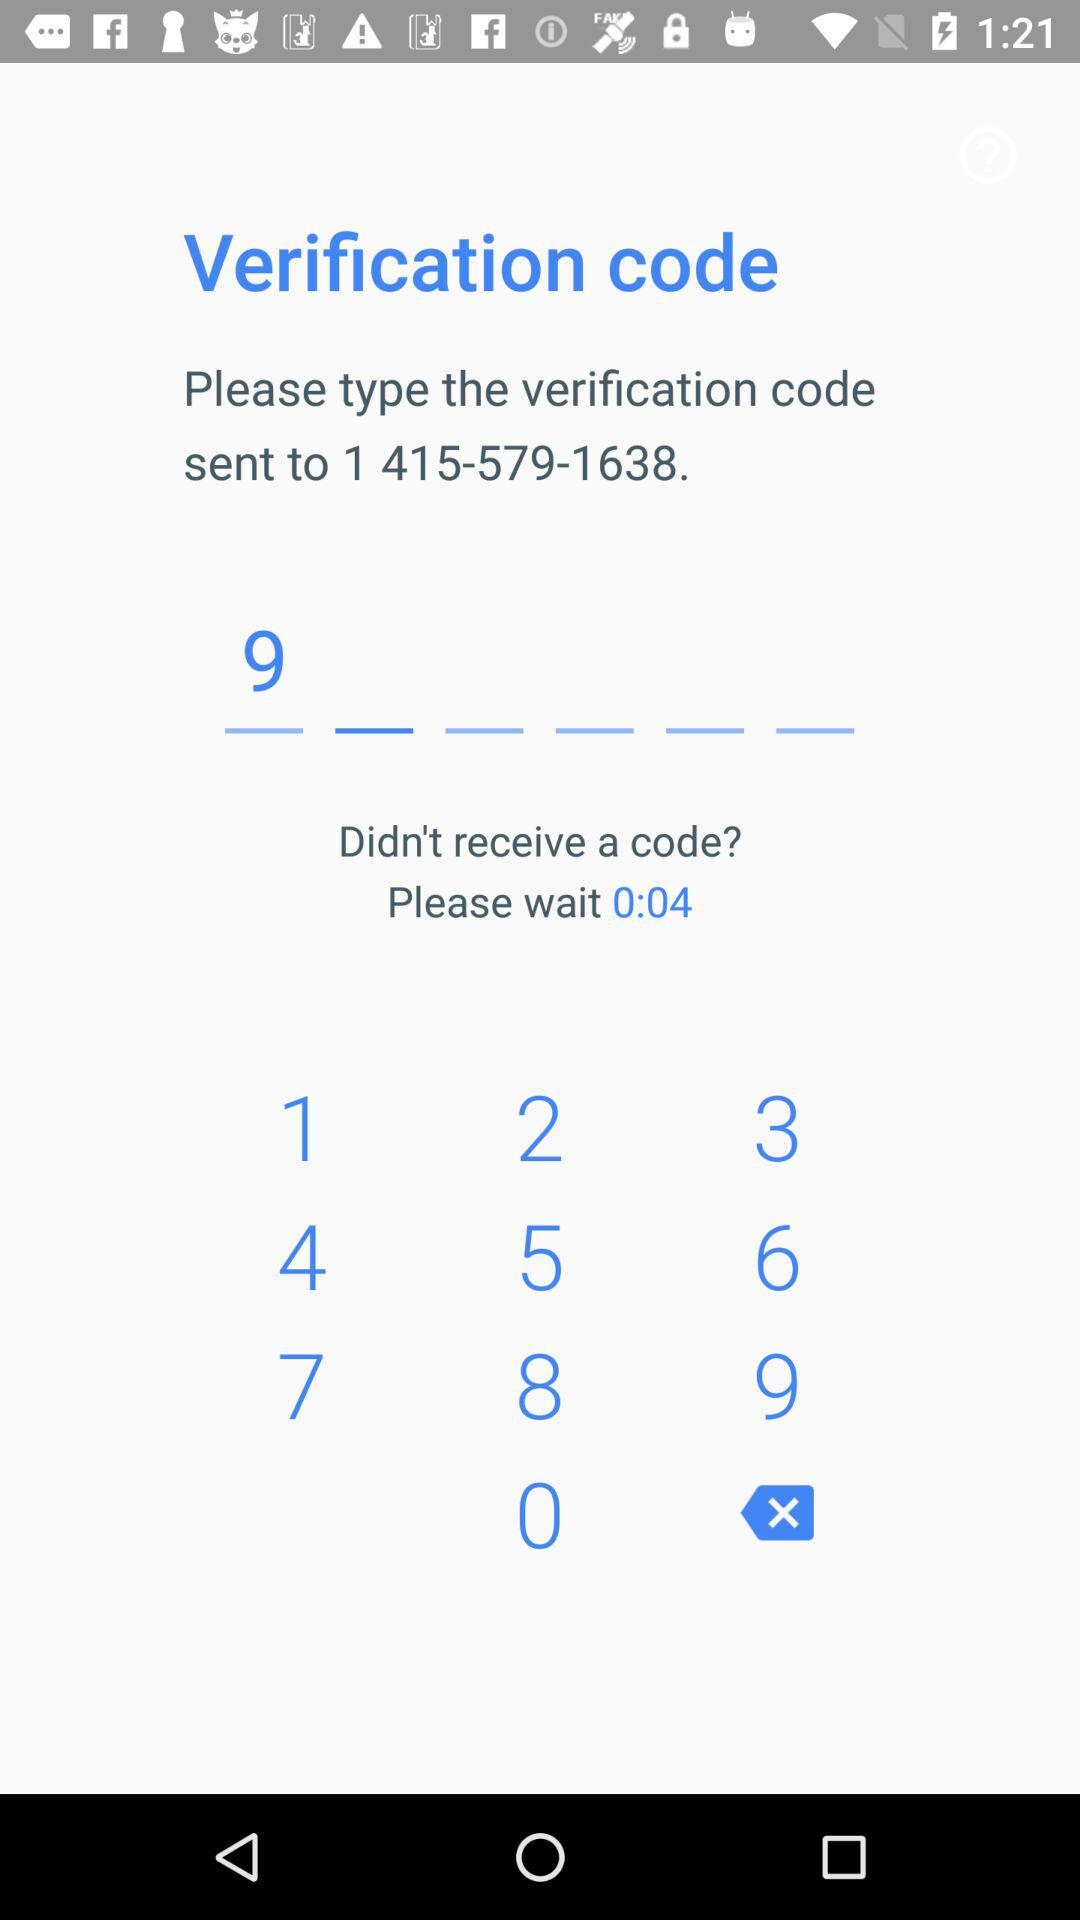What is the verification code?
When the provided information is insufficient, respond with <no answer>. <no answer> 